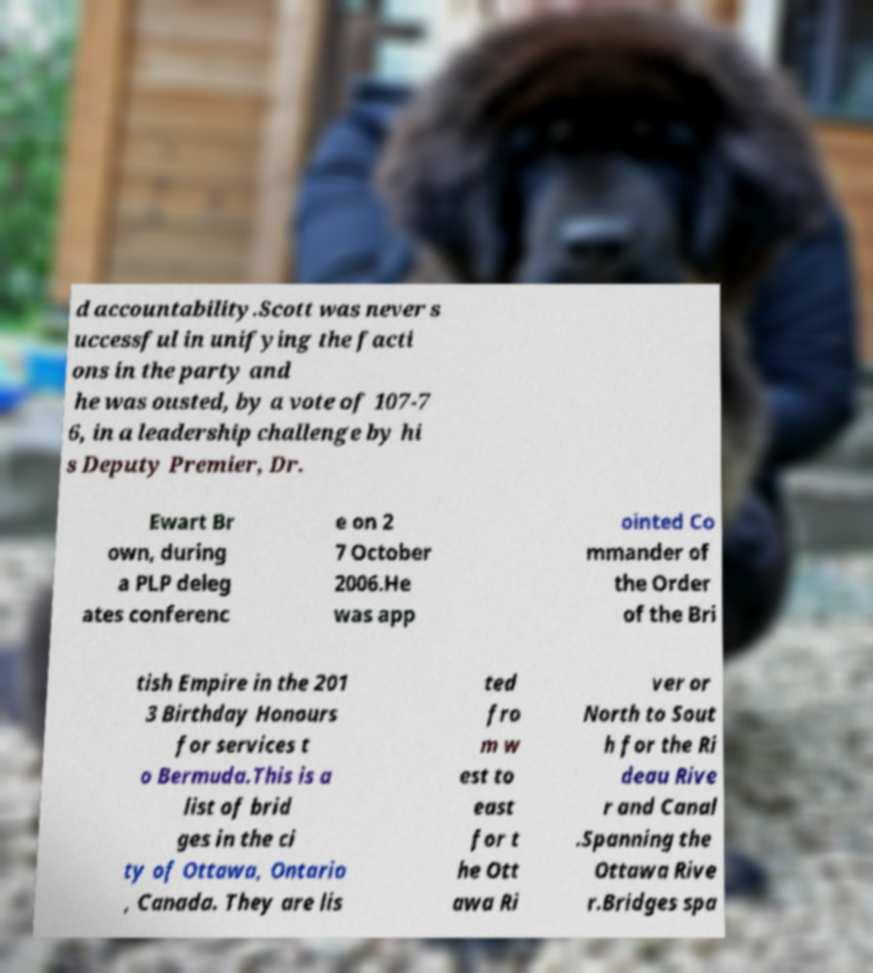Please identify and transcribe the text found in this image. d accountability.Scott was never s uccessful in unifying the facti ons in the party and he was ousted, by a vote of 107-7 6, in a leadership challenge by hi s Deputy Premier, Dr. Ewart Br own, during a PLP deleg ates conferenc e on 2 7 October 2006.He was app ointed Co mmander of the Order of the Bri tish Empire in the 201 3 Birthday Honours for services t o Bermuda.This is a list of brid ges in the ci ty of Ottawa, Ontario , Canada. They are lis ted fro m w est to east for t he Ott awa Ri ver or North to Sout h for the Ri deau Rive r and Canal .Spanning the Ottawa Rive r.Bridges spa 